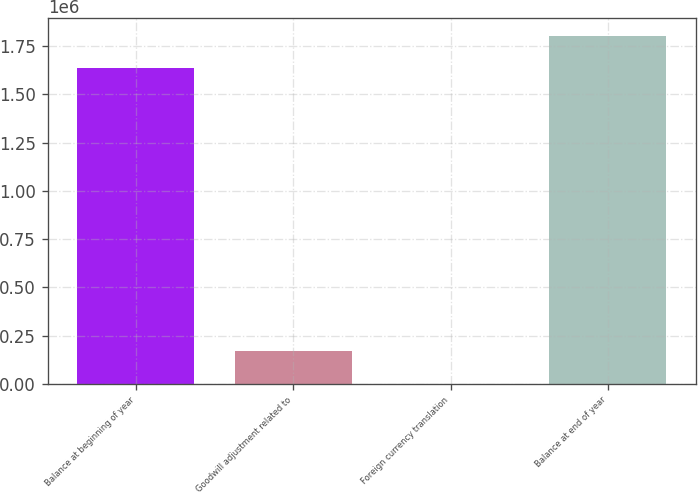Convert chart to OTSL. <chart><loc_0><loc_0><loc_500><loc_500><bar_chart><fcel>Balance at beginning of year<fcel>Goodwill adjustment related to<fcel>Foreign currency translation<fcel>Balance at end of year<nl><fcel>1.63653e+06<fcel>169222<fcel>1456<fcel>1.80429e+06<nl></chart> 